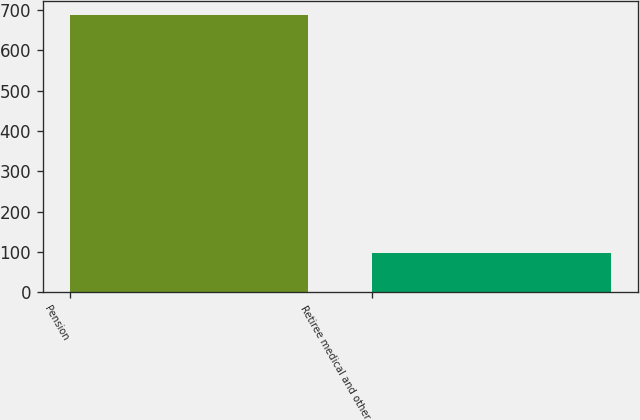<chart> <loc_0><loc_0><loc_500><loc_500><bar_chart><fcel>Pension<fcel>Retiree medical and other<nl><fcel>688<fcel>97<nl></chart> 